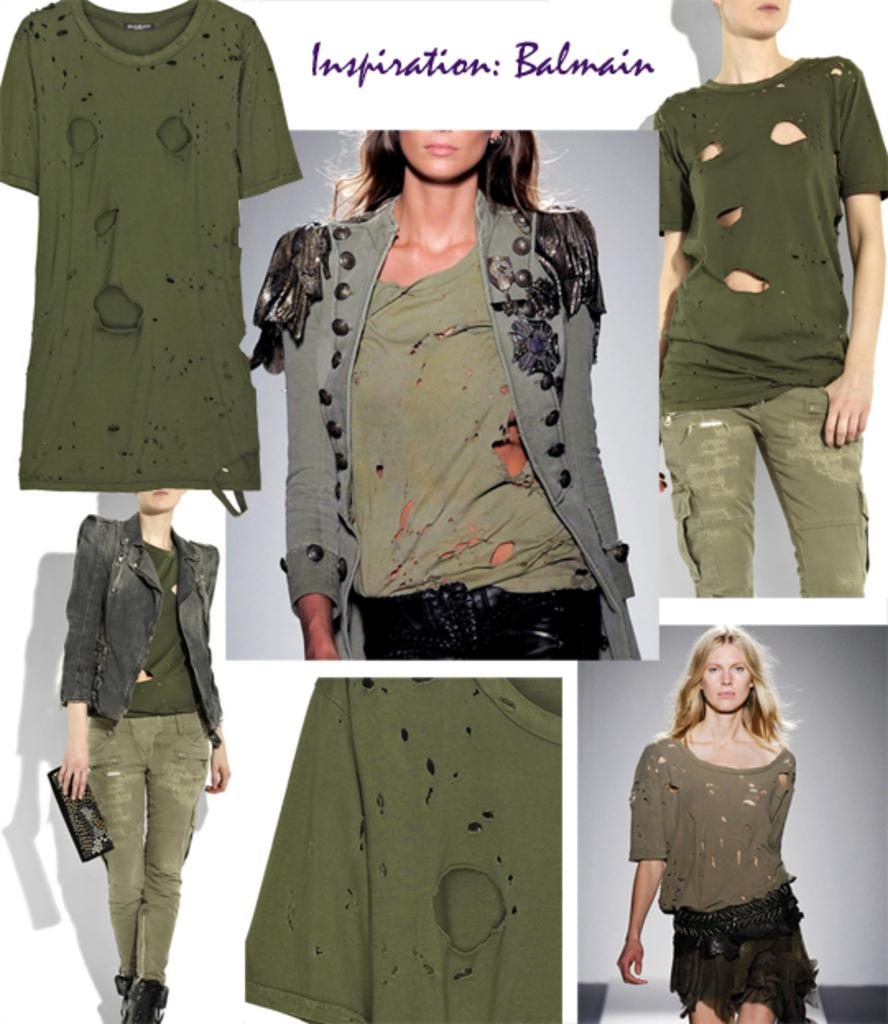How many photographs are present in the image? There are six collage photographs in the image. What is the common subject in each photograph? Each photograph features a girl. What is the girl wearing in each photograph? The girl is wearing a green color t-shirt in each photograph. What is the girl doing in each photograph? The girl is walking on a ramp in each photograph. What type of crib is visible in the image? There is no crib present in the image; it features six collage photographs of a girl walking on a ramp. 